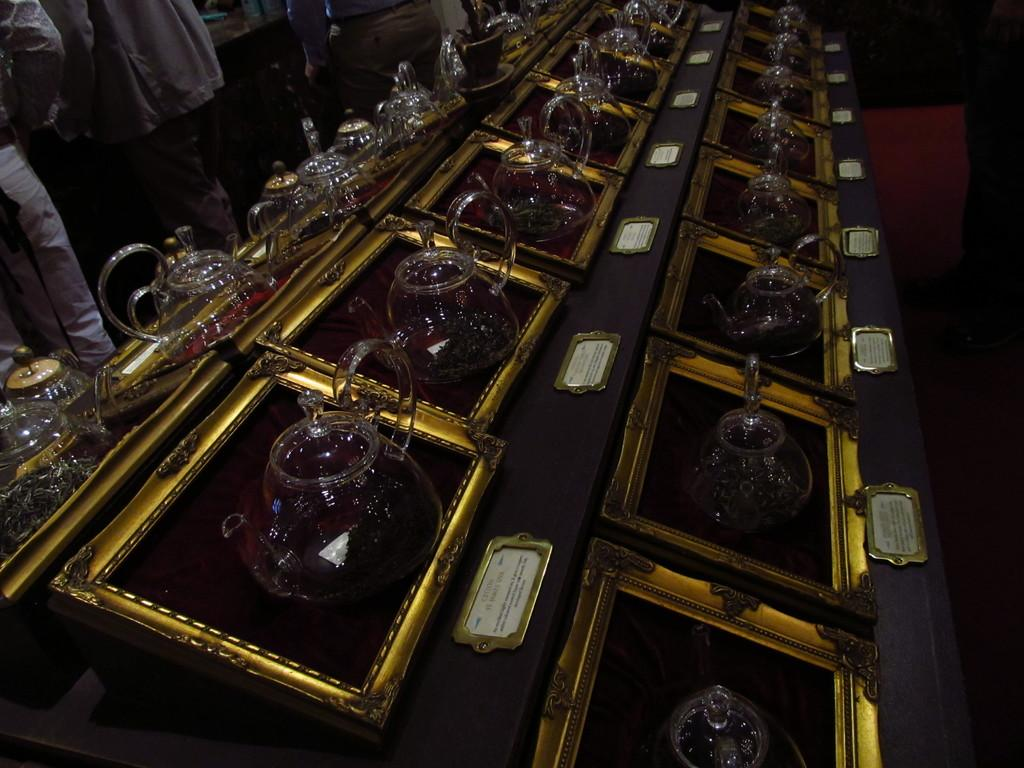What objects are on the desk in the image? There are jugs on the desk in the image. Where are the people located in the image? The people are on the left side of the image. What type of hill can be seen in the background of the image? There is no hill visible in the image; it only shows jugs on a desk and people on the left side. What kind of linen is being discussed by the people in the image? There is no indication of a discussion about linen or any other topic in the image. 